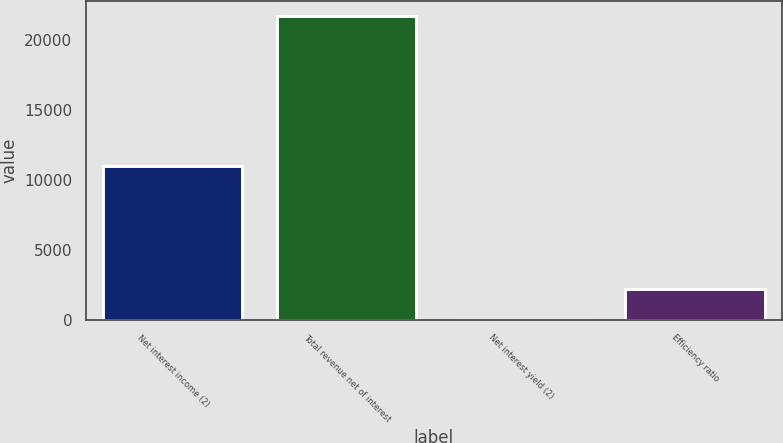Convert chart to OTSL. <chart><loc_0><loc_0><loc_500><loc_500><bar_chart><fcel>Net interest income (2)<fcel>Total revenue net of interest<fcel>Net interest yield (2)<fcel>Efficiency ratio<nl><fcel>10999<fcel>21701<fcel>2.44<fcel>2172.3<nl></chart> 